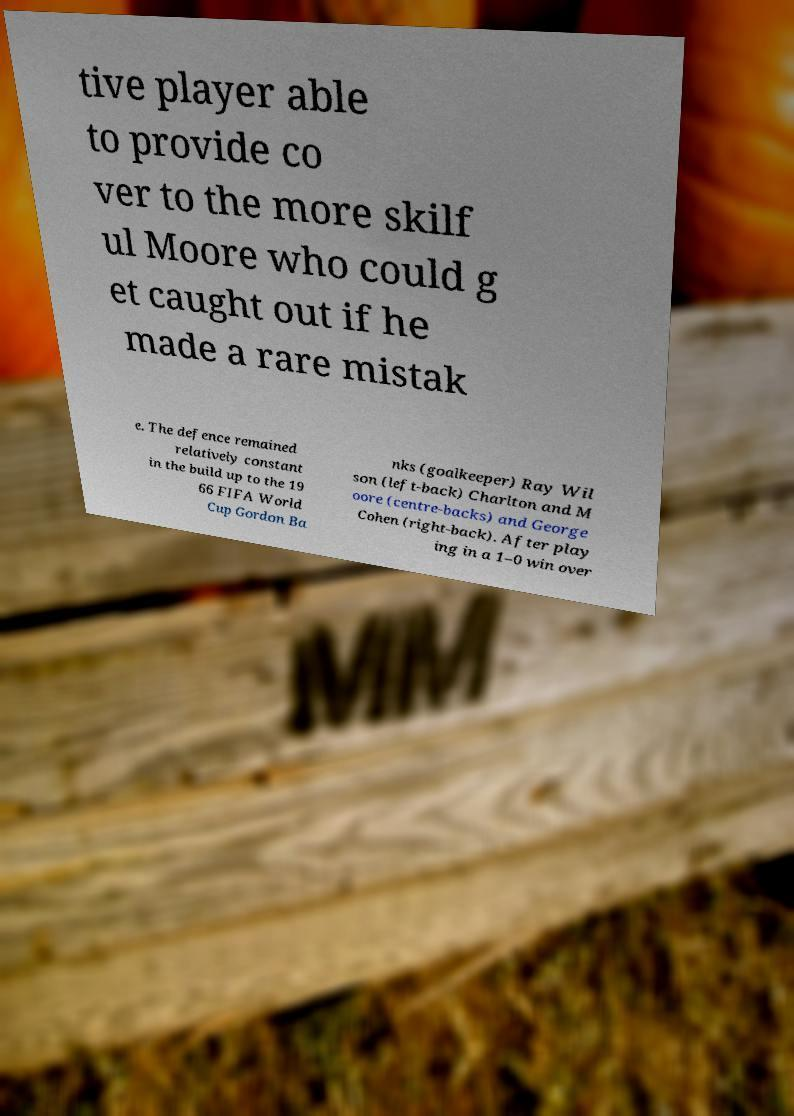I need the written content from this picture converted into text. Can you do that? tive player able to provide co ver to the more skilf ul Moore who could g et caught out if he made a rare mistak e. The defence remained relatively constant in the build up to the 19 66 FIFA World Cup Gordon Ba nks (goalkeeper) Ray Wil son (left-back) Charlton and M oore (centre-backs) and George Cohen (right-back). After play ing in a 1–0 win over 